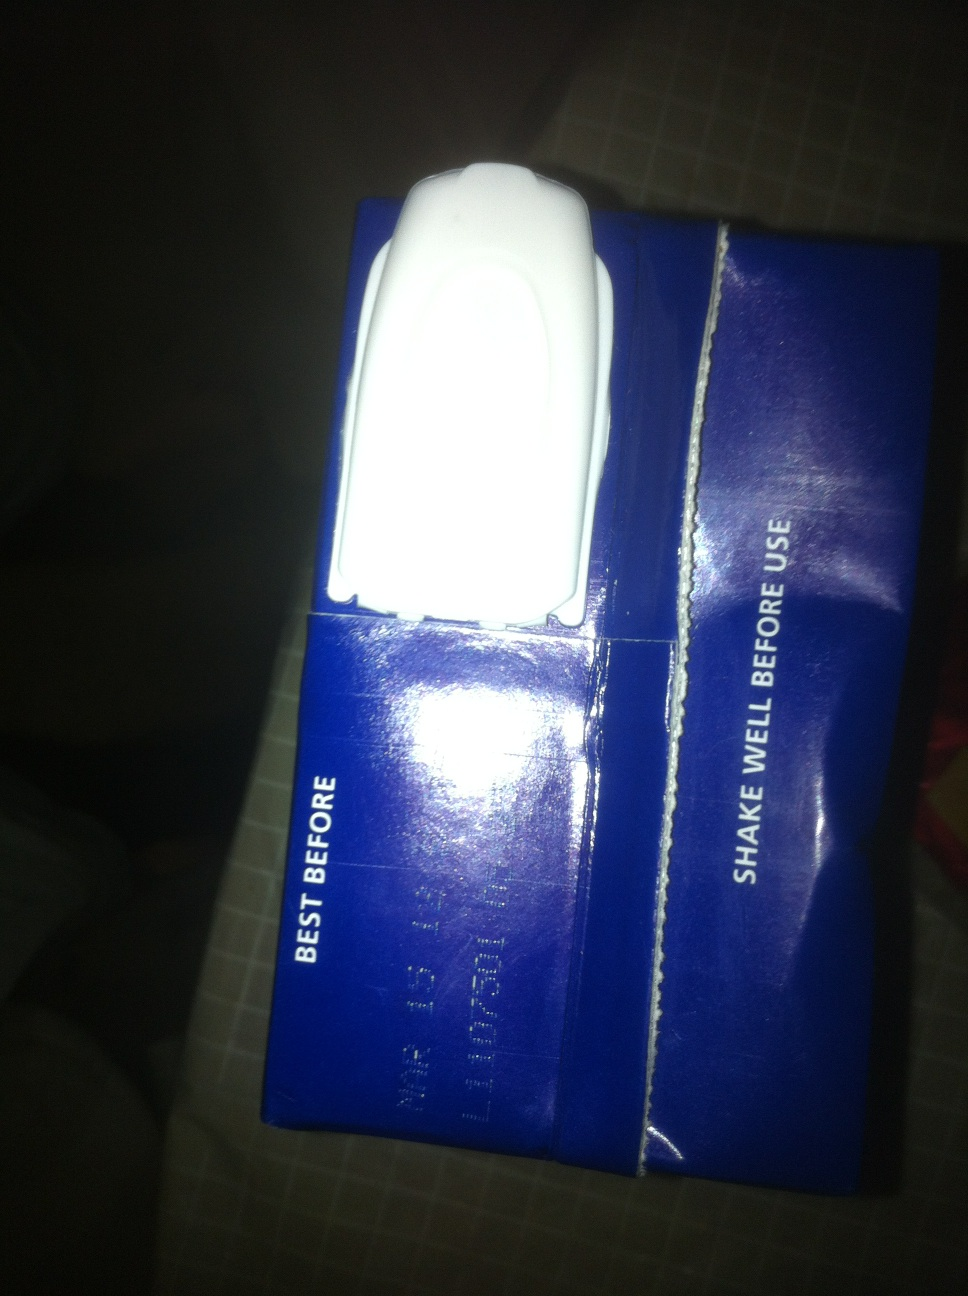What type of product is this, and what are its storage instructions? This appears to be a carton, likely for a beverage such as juice or milk. The packaging advises to 'Shake well before use', indicating it contains a liquid that may settle, so shaking is necessary for proper consistency before drinking. Is there any specific way to dispose of this type of packaging? Yes, this type of packaging is typically recyclable. Check for local recycling guidelines to properly dispose of it. Sometimes, the packaging needs to be rinsed and flattened before recycling to meet local recycling standards. 